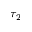Convert formula to latex. <formula><loc_0><loc_0><loc_500><loc_500>\tau _ { 2 }</formula> 